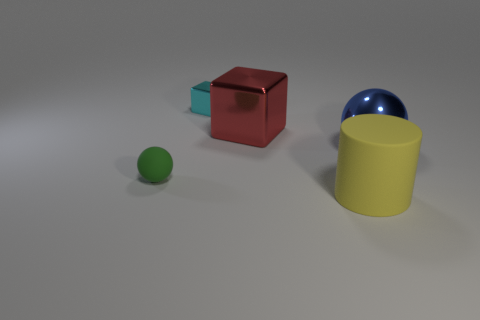There is a rubber object on the right side of the sphere that is to the left of the large yellow thing; is there a big yellow matte thing left of it?
Offer a terse response. No. What shape is the cyan metallic thing that is the same size as the green sphere?
Offer a terse response. Cube. There is a small matte thing that is the same shape as the blue metallic thing; what color is it?
Provide a succinct answer. Green. How many things are either red matte things or small green spheres?
Your answer should be very brief. 1. Is the shape of the thing on the right side of the large yellow rubber cylinder the same as the small object right of the green thing?
Ensure brevity in your answer.  No. The large object that is to the left of the rubber cylinder has what shape?
Give a very brief answer. Cube. Is the number of large matte objects to the right of the large matte thing the same as the number of small things right of the small ball?
Your answer should be very brief. No. What number of objects are either green spheres or metal objects behind the large blue object?
Your answer should be very brief. 3. What shape is the object that is behind the tiny green matte ball and left of the large shiny block?
Provide a short and direct response. Cube. There is a thing that is in front of the rubber thing behind the yellow rubber thing; what is it made of?
Give a very brief answer. Rubber. 